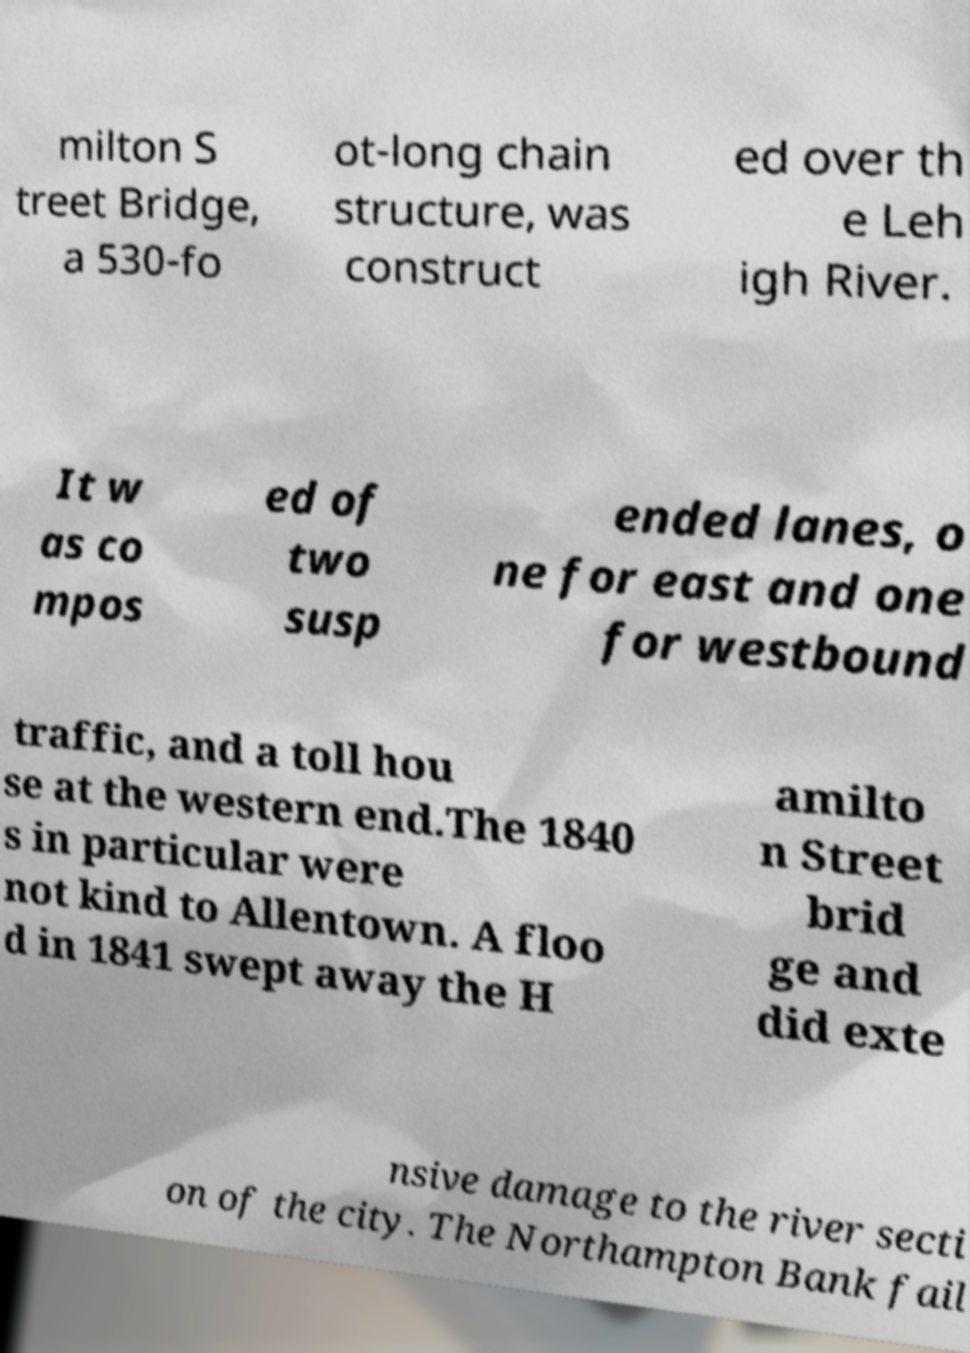Could you assist in decoding the text presented in this image and type it out clearly? milton S treet Bridge, a 530-fo ot-long chain structure, was construct ed over th e Leh igh River. It w as co mpos ed of two susp ended lanes, o ne for east and one for westbound traffic, and a toll hou se at the western end.The 1840 s in particular were not kind to Allentown. A floo d in 1841 swept away the H amilto n Street brid ge and did exte nsive damage to the river secti on of the city. The Northampton Bank fail 